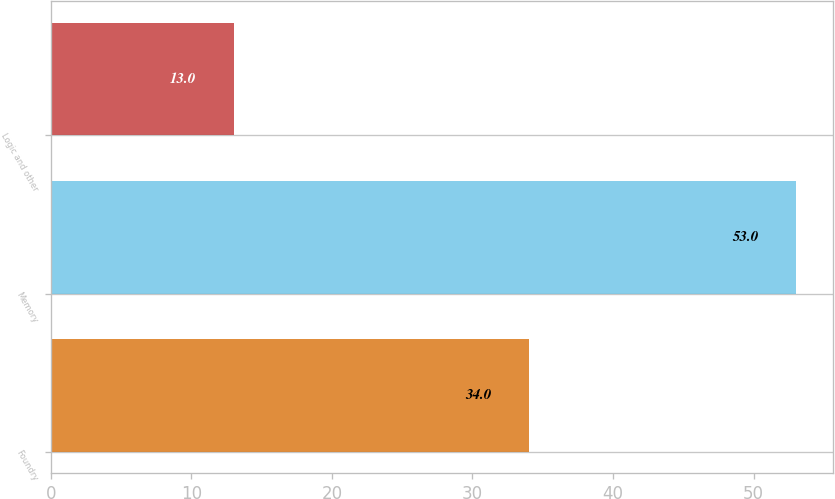<chart> <loc_0><loc_0><loc_500><loc_500><bar_chart><fcel>Foundry<fcel>Memory<fcel>Logic and other<nl><fcel>34<fcel>53<fcel>13<nl></chart> 